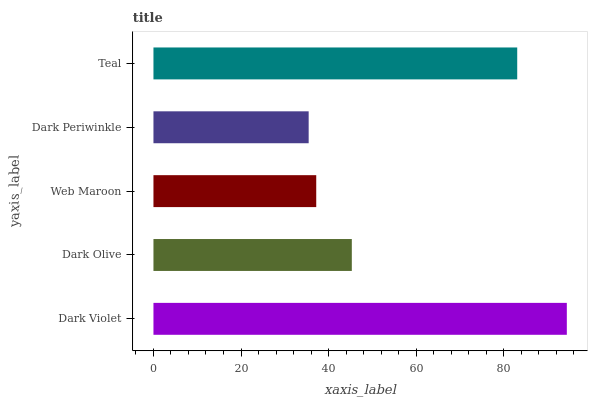Is Dark Periwinkle the minimum?
Answer yes or no. Yes. Is Dark Violet the maximum?
Answer yes or no. Yes. Is Dark Olive the minimum?
Answer yes or no. No. Is Dark Olive the maximum?
Answer yes or no. No. Is Dark Violet greater than Dark Olive?
Answer yes or no. Yes. Is Dark Olive less than Dark Violet?
Answer yes or no. Yes. Is Dark Olive greater than Dark Violet?
Answer yes or no. No. Is Dark Violet less than Dark Olive?
Answer yes or no. No. Is Dark Olive the high median?
Answer yes or no. Yes. Is Dark Olive the low median?
Answer yes or no. Yes. Is Web Maroon the high median?
Answer yes or no. No. Is Dark Violet the low median?
Answer yes or no. No. 